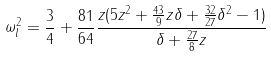Convert formula to latex. <formula><loc_0><loc_0><loc_500><loc_500>\omega _ { l } ^ { 2 } = \frac { 3 } { 4 } + \frac { 8 1 } { 6 4 } \frac { z ( 5 z ^ { 2 } + \frac { 4 3 } { 9 } z \delta + \frac { 3 2 } { 2 7 } \delta ^ { 2 } - 1 ) } { \delta + \frac { 2 7 } { 8 } z } \\</formula> 